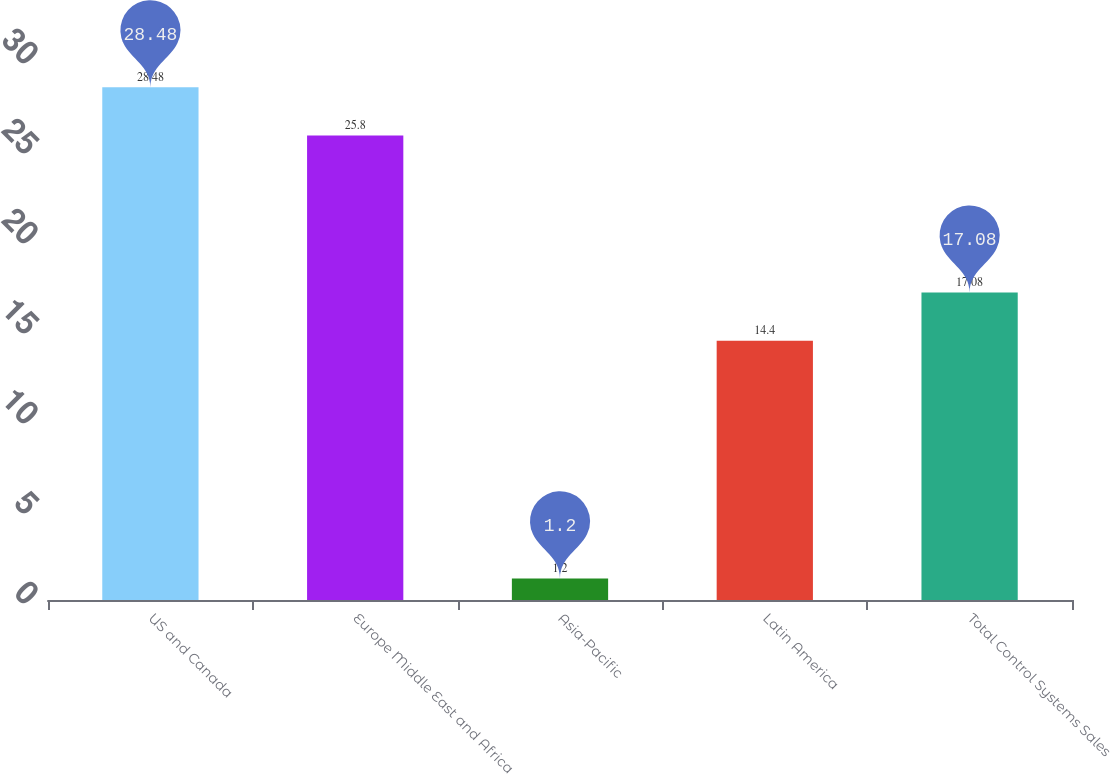Convert chart. <chart><loc_0><loc_0><loc_500><loc_500><bar_chart><fcel>US and Canada<fcel>Europe Middle East and Africa<fcel>Asia-Pacific<fcel>Latin America<fcel>Total Control Systems Sales<nl><fcel>28.48<fcel>25.8<fcel>1.2<fcel>14.4<fcel>17.08<nl></chart> 